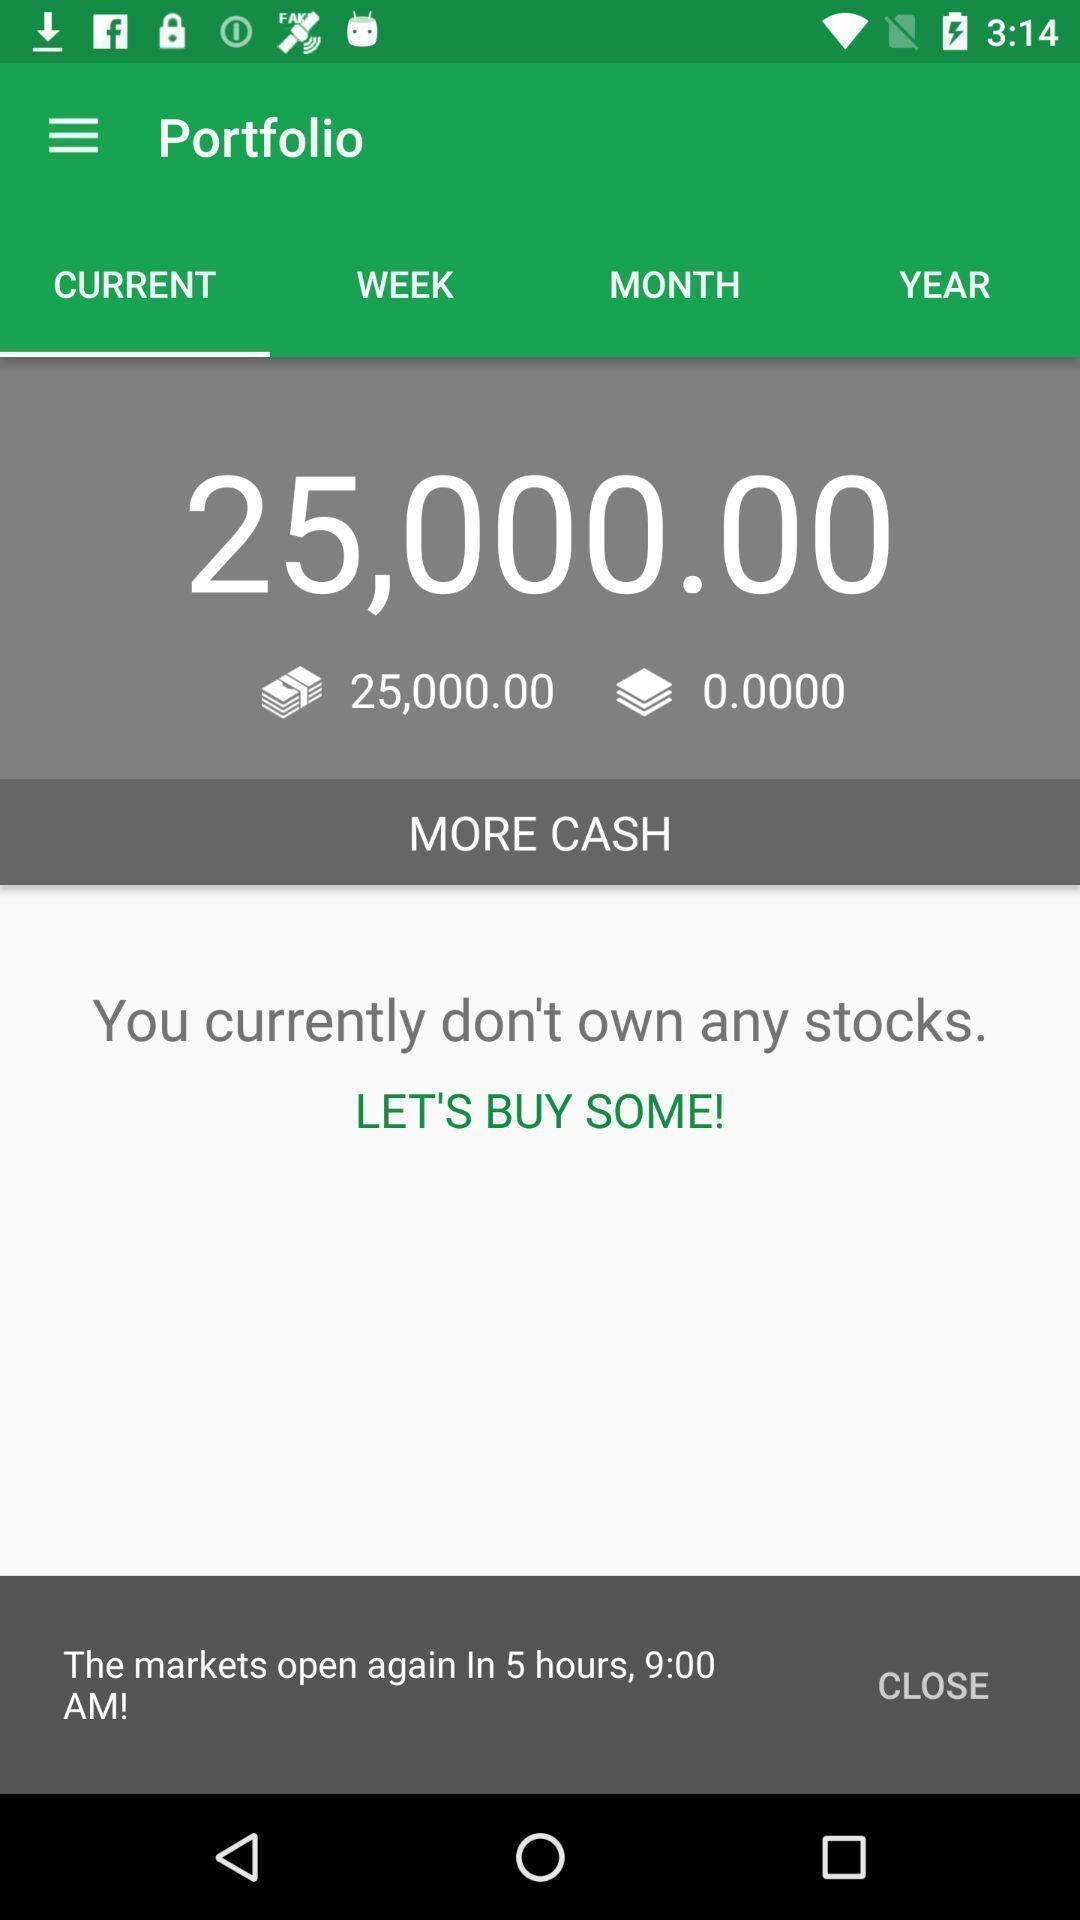What can you discern from this picture? Screen showing current. 